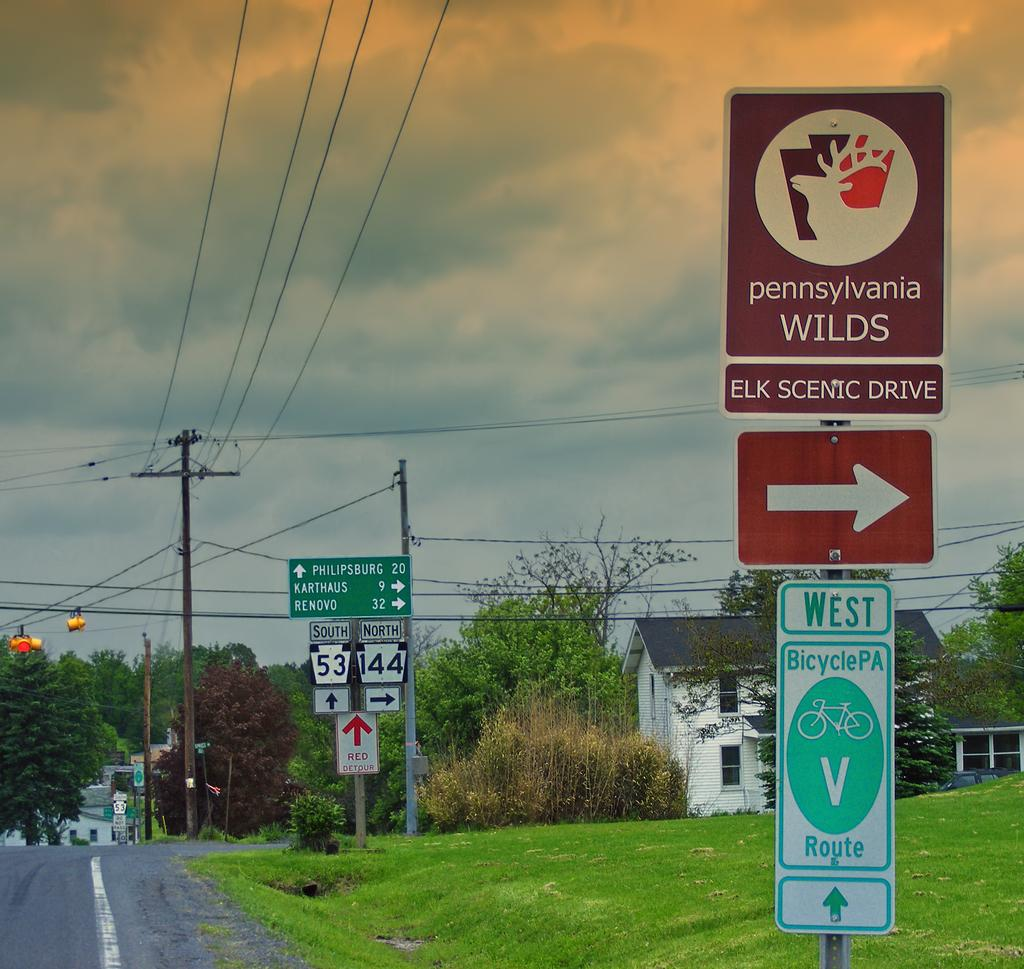<image>
Give a short and clear explanation of the subsequent image. Philipsburg is 20 miles South down the road. 